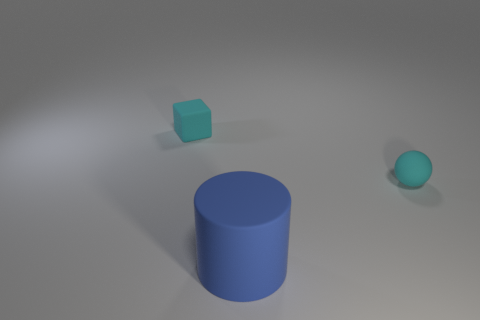Is there any other thing that is the same size as the blue matte cylinder?
Offer a terse response. No. What number of small objects have the same color as the ball?
Your response must be concise. 1. Is the number of small cyan objects that are in front of the small cube greater than the number of big yellow metallic cubes?
Give a very brief answer. Yes. The small thing on the right side of the cyan thing that is to the left of the blue thing is what color?
Your response must be concise. Cyan. How many objects are small things on the right side of the cyan cube or tiny cyan objects that are on the right side of the matte block?
Your answer should be compact. 1. The block has what color?
Make the answer very short. Cyan. What number of big cylinders are made of the same material as the big blue object?
Your answer should be compact. 0. Are there more cyan spheres than cyan rubber things?
Your answer should be very brief. No. How many cylinders are on the right side of the cyan matte thing on the right side of the big rubber cylinder?
Your response must be concise. 0. How many things are cyan things that are on the left side of the small ball or large yellow balls?
Keep it short and to the point. 1. 